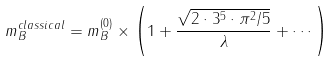<formula> <loc_0><loc_0><loc_500><loc_500>m _ { B } ^ { c l a s s i c a l } = m _ { B } ^ { ( 0 ) } \times \left ( 1 + \frac { \sqrt { 2 \cdot 3 ^ { 5 } \cdot \pi ^ { 2 } / 5 } } { \lambda } + \cdots \right )</formula> 